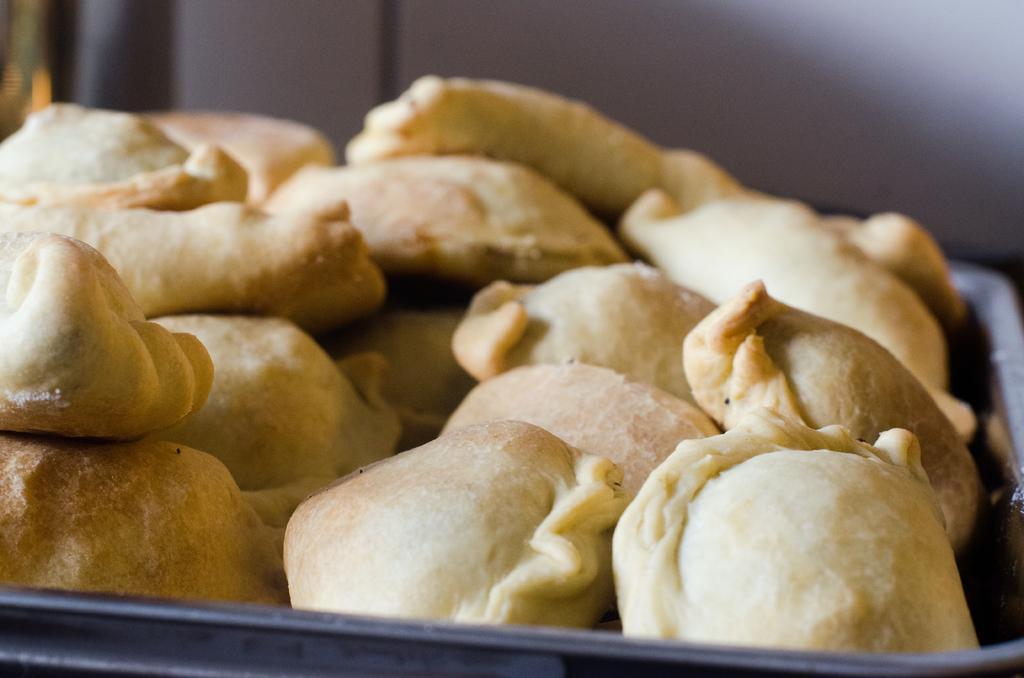In one or two sentences, can you explain what this image depicts? In this image, there is a tray, in that tree there are some food items kept. 